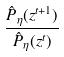<formula> <loc_0><loc_0><loc_500><loc_500>\frac { \hat { P } _ { \eta } ( z ^ { t + 1 } ) } { \hat { P } _ { \eta } ( z ^ { t } ) }</formula> 